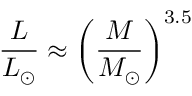<formula> <loc_0><loc_0><loc_500><loc_500>{ \frac { L } { L _ { \odot } } } \approx { \left ( { \frac { M } { M _ { \odot } } } \right ) } ^ { 3 . 5 }</formula> 